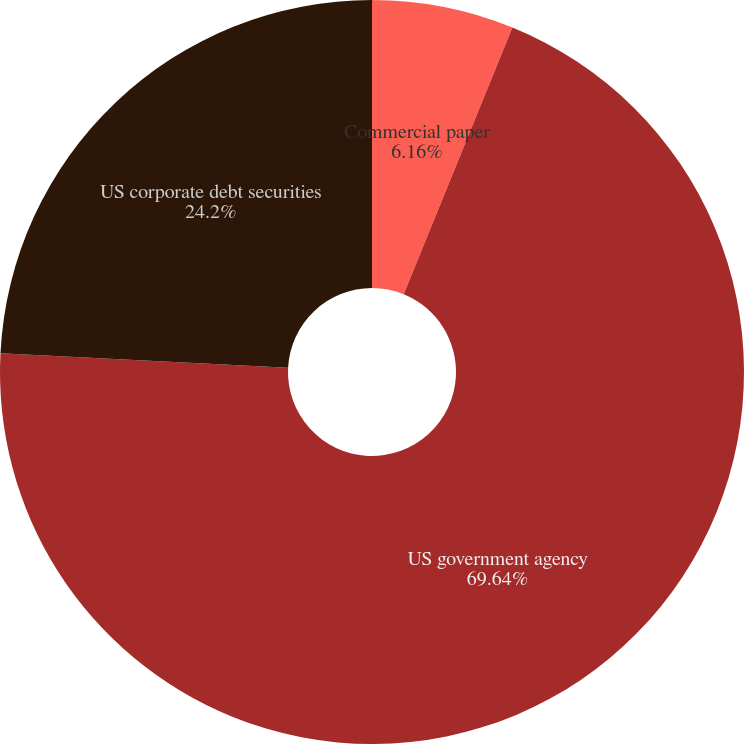<chart> <loc_0><loc_0><loc_500><loc_500><pie_chart><fcel>Commercial paper<fcel>US government agency<fcel>US corporate debt securities<nl><fcel>6.16%<fcel>69.63%<fcel>24.2%<nl></chart> 